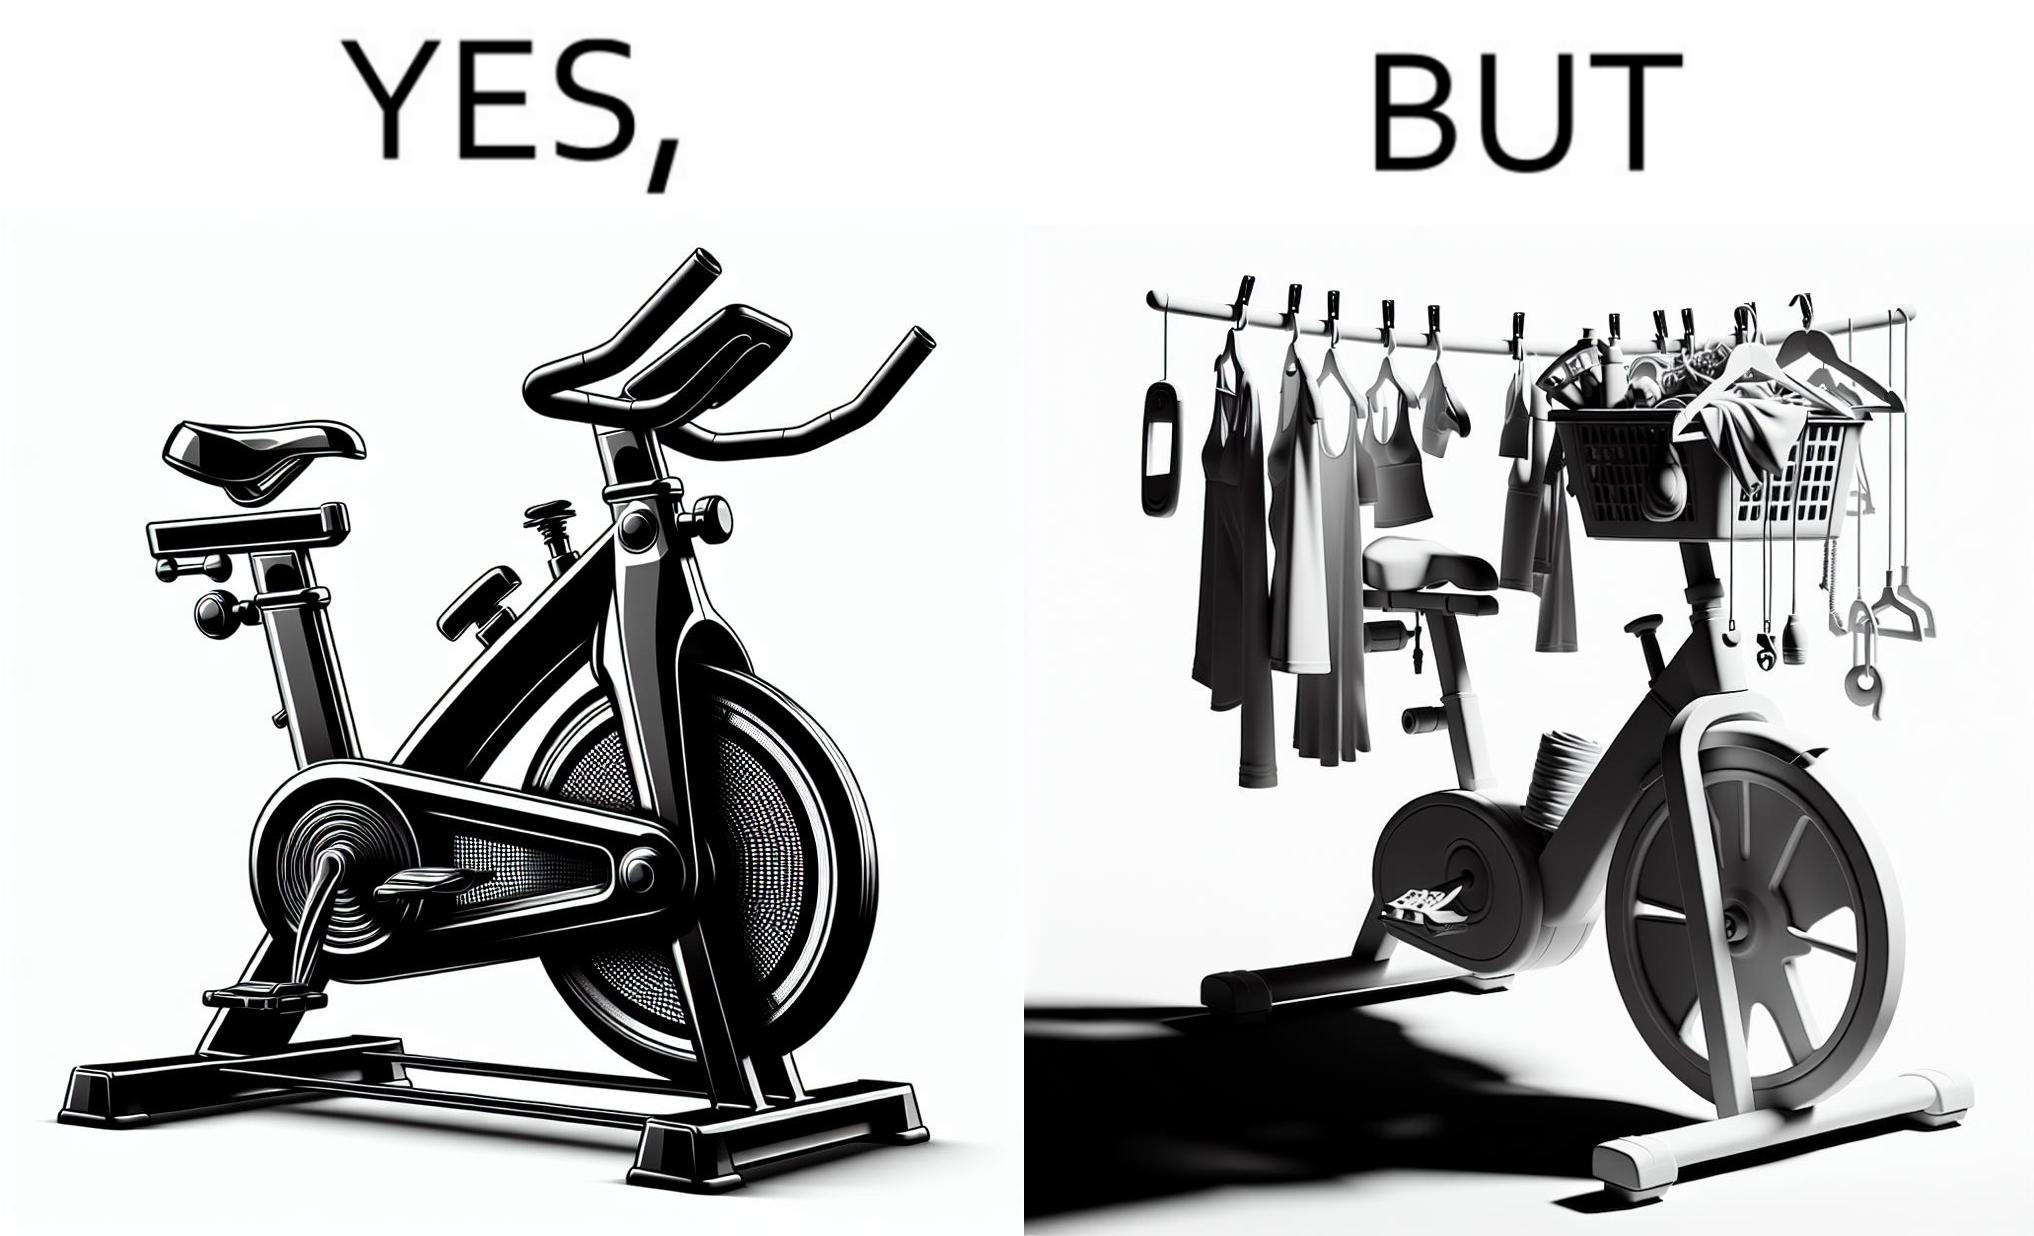Provide a description of this image. The images are funny since they show an exercise bike has been bought but is not being used for its purpose, that is, exercising. It is rather being used to hang clothes, bags and other items 